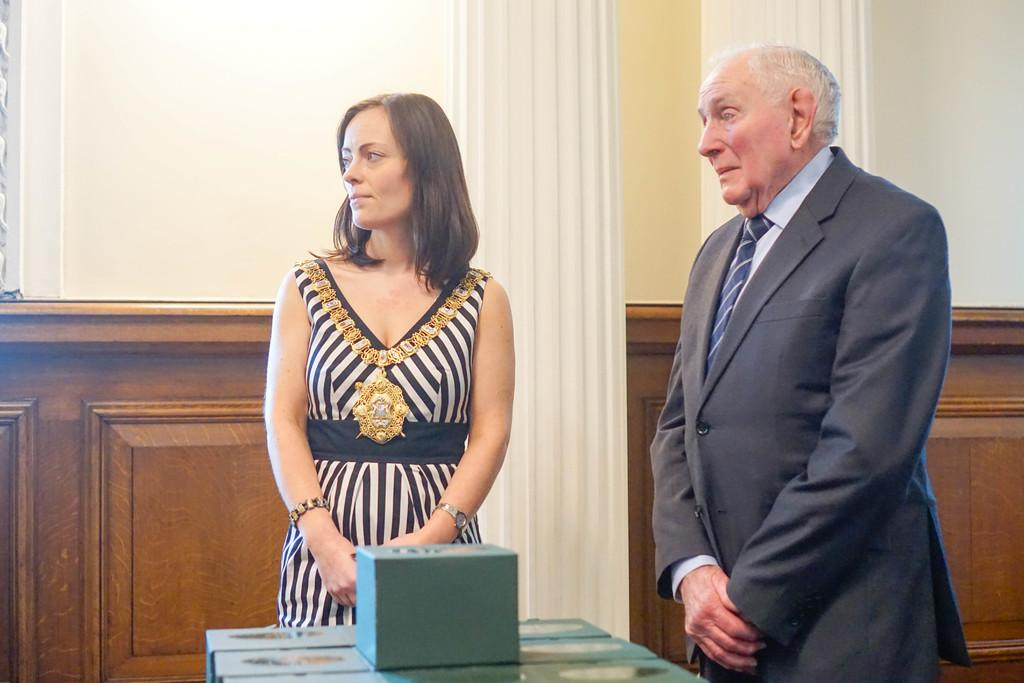How many people are present in the image? There are two persons standing in the image. What else can be seen in the image besides the people? There are objects in the image. What can be seen in the background of the image? There is a wall, pillars, and a wooden fence in the background of the image. Can you describe the setting where the image might have been taken? The image may have been taken in a hall, based on the presence of pillars and a wall. What type of tail can be seen on the car in the image? There is no car present in the image, so there is no tail to observe. 